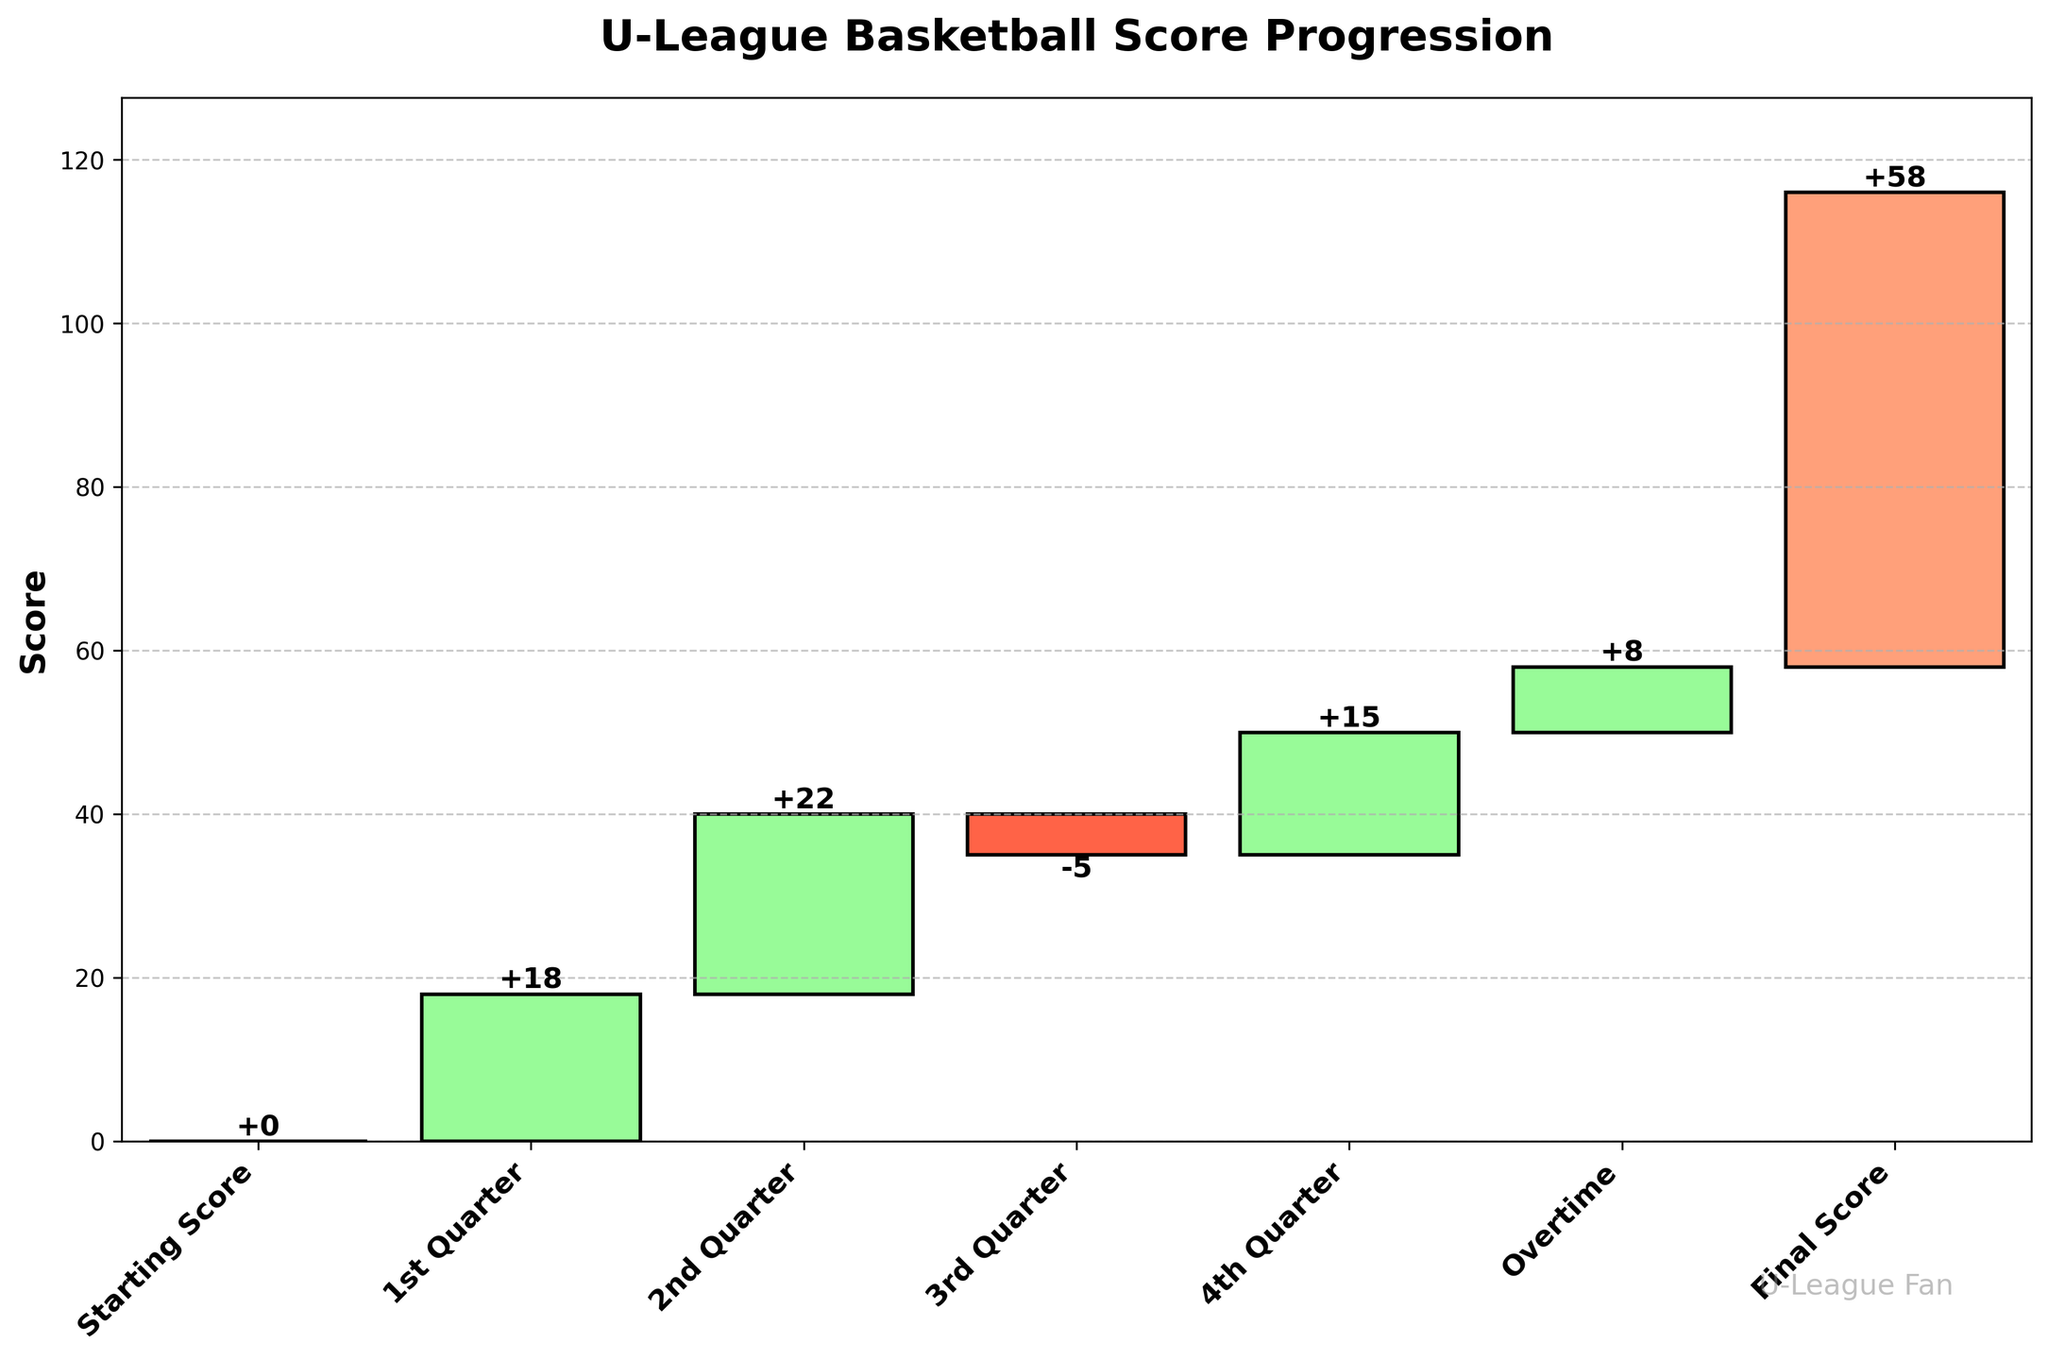What is the final score of the basketball game? The final score is represented by the last bar in the chart, which corresponds to the "Final Score" category.
Answer: 58 How many points were scored in the 4th quarter? Find the bar labeled "4th Quarter" and look at the value inside the bar. The value inside the bar for the 4th quarter is 15.
Answer: 15 Did the team lose points in any quarter, and if so, which one? Identify any bar with a negative value. Here, the bar labeled "3rd Quarter" has a value of -5, indicating a loss of points.
Answer: 3rd Quarter What was the score at halftime (after the 2nd quarter)? To determine the score at halftime, sum the points from the "Starting Score", "1st Quarter", and "2nd Quarter": 0 + 18 + 22 = 40.
Answer: 40 Compare the points scored in the 1st and 4th quarters. Which one had more points, and by how much? Look at the values for the "1st Quarter" and "4th Quarter". The 1st Quarter has 18 points, and the 4th Quarter has 15 points. The difference is 18 - 15 = 3 points.
Answer: 1st Quarter by 3 points What was the total point gain between the end of the 2nd quarter and the beginning of the 4th quarter? Calculate the sum of the points scored in the "3rd Quarter" and add them: 22 (end of 2nd quarter) - 5 (3rd Quarter) = 17.
Answer: 17 What proportion of the final score was achieved during overtime? The final score is 58, and the points in overtime are 8. The proportion is calculated as 8/58. Approximately, this is 0.1379 or about 13.8%.
Answer: 13.8% Which quarter contributed the most to the team's score? Compare the values across all quarters. The "1st Quarter" has the highest value with 18 points.
Answer: 1st Quarter What was the cumulative score at the end of the 3rd quarter? To find the cumulative score at the end of the 3rd quarter, sum all scores up to and including the 3rd quarter: 0 (Starting Score) + 18 (1st Quarter) + 22 (2nd Quarter) - 5 (3rd Quarter) = 35.
Answer: 35 